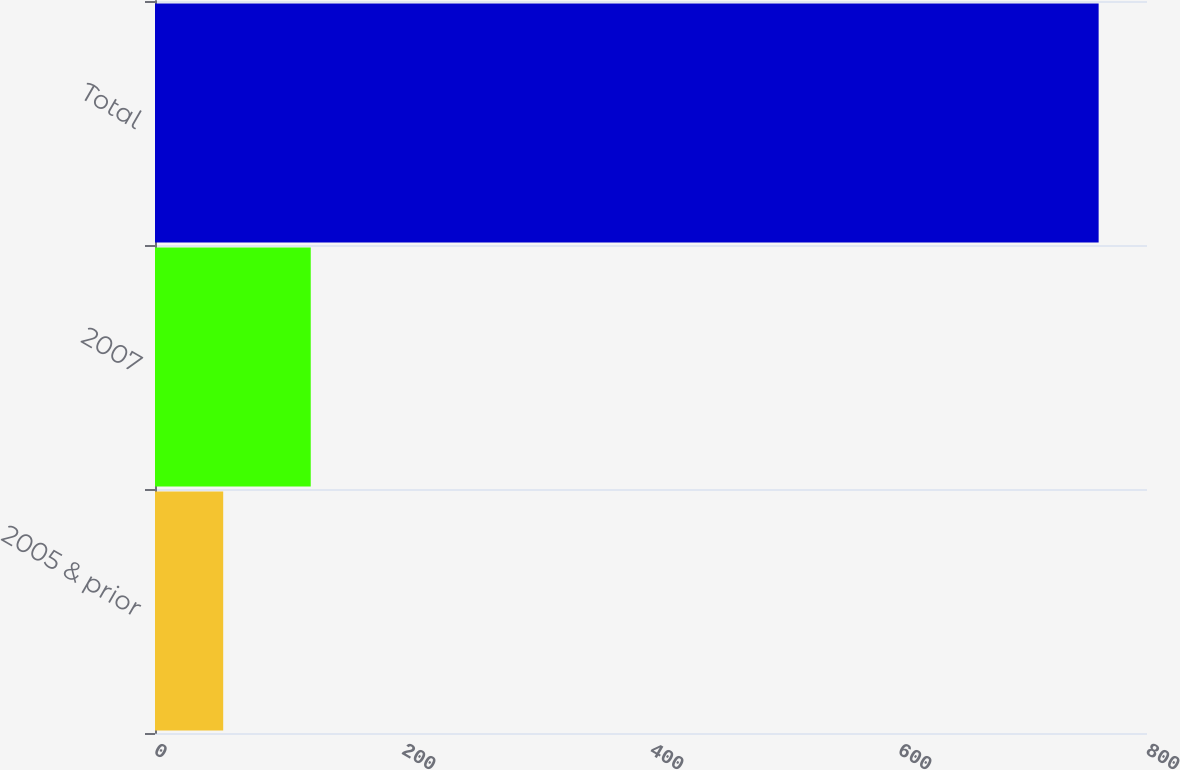Convert chart to OTSL. <chart><loc_0><loc_0><loc_500><loc_500><bar_chart><fcel>2005 & prior<fcel>2007<fcel>Total<nl><fcel>55<fcel>125.6<fcel>761<nl></chart> 